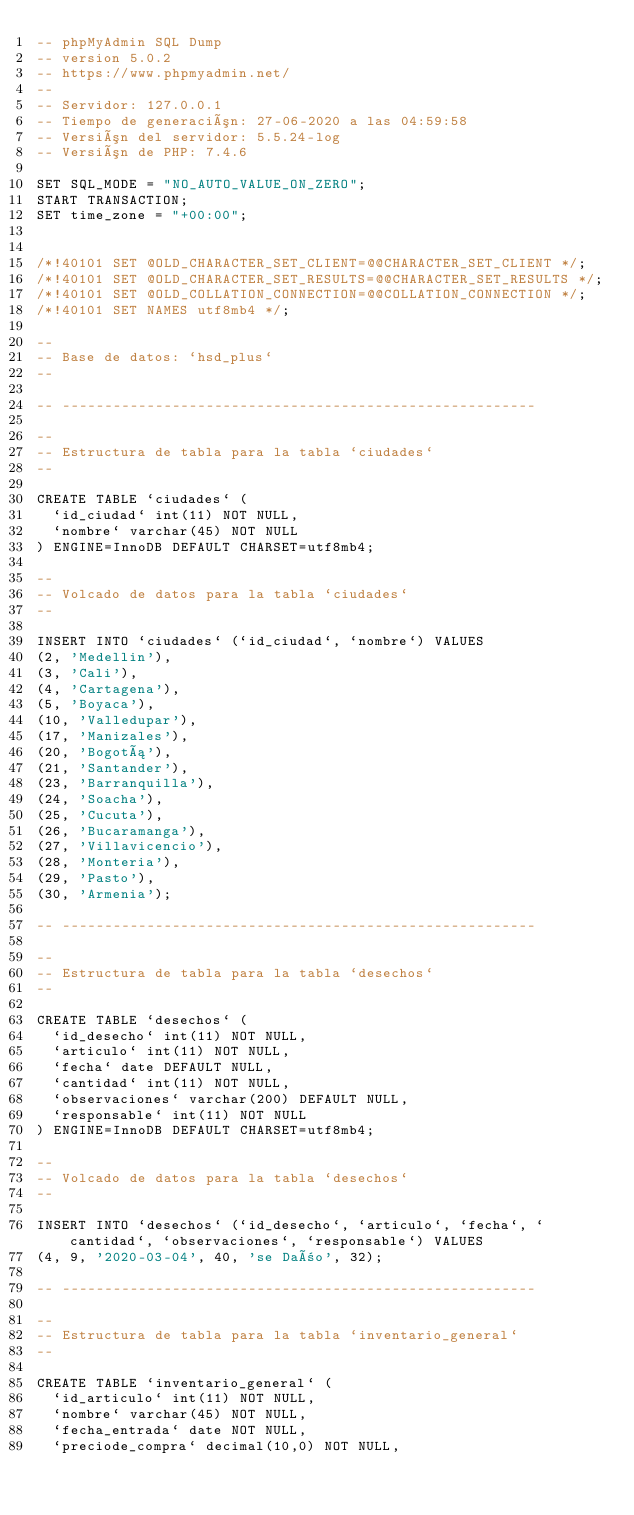<code> <loc_0><loc_0><loc_500><loc_500><_SQL_>-- phpMyAdmin SQL Dump
-- version 5.0.2
-- https://www.phpmyadmin.net/
--
-- Servidor: 127.0.0.1
-- Tiempo de generación: 27-06-2020 a las 04:59:58
-- Versión del servidor: 5.5.24-log
-- Versión de PHP: 7.4.6

SET SQL_MODE = "NO_AUTO_VALUE_ON_ZERO";
START TRANSACTION;
SET time_zone = "+00:00";


/*!40101 SET @OLD_CHARACTER_SET_CLIENT=@@CHARACTER_SET_CLIENT */;
/*!40101 SET @OLD_CHARACTER_SET_RESULTS=@@CHARACTER_SET_RESULTS */;
/*!40101 SET @OLD_COLLATION_CONNECTION=@@COLLATION_CONNECTION */;
/*!40101 SET NAMES utf8mb4 */;

--
-- Base de datos: `hsd_plus`
--

-- --------------------------------------------------------

--
-- Estructura de tabla para la tabla `ciudades`
--

CREATE TABLE `ciudades` (
  `id_ciudad` int(11) NOT NULL,
  `nombre` varchar(45) NOT NULL
) ENGINE=InnoDB DEFAULT CHARSET=utf8mb4;

--
-- Volcado de datos para la tabla `ciudades`
--

INSERT INTO `ciudades` (`id_ciudad`, `nombre`) VALUES
(2, 'Medellin'),
(3, 'Cali'),
(4, 'Cartagena'),
(5, 'Boyaca'),
(10, 'Valledupar'),
(17, 'Manizales'),
(20, 'Bogotá'),
(21, 'Santander'),
(23, 'Barranquilla'),
(24, 'Soacha'),
(25, 'Cucuta'),
(26, 'Bucaramanga'),
(27, 'Villavicencio'),
(28, 'Monteria'),
(29, 'Pasto'),
(30, 'Armenia');

-- --------------------------------------------------------

--
-- Estructura de tabla para la tabla `desechos`
--

CREATE TABLE `desechos` (
  `id_desecho` int(11) NOT NULL,
  `articulo` int(11) NOT NULL,
  `fecha` date DEFAULT NULL,
  `cantidad` int(11) NOT NULL,
  `observaciones` varchar(200) DEFAULT NULL,
  `responsable` int(11) NOT NULL
) ENGINE=InnoDB DEFAULT CHARSET=utf8mb4;

--
-- Volcado de datos para la tabla `desechos`
--

INSERT INTO `desechos` (`id_desecho`, `articulo`, `fecha`, `cantidad`, `observaciones`, `responsable`) VALUES
(4, 9, '2020-03-04', 40, 'se Daño', 32);

-- --------------------------------------------------------

--
-- Estructura de tabla para la tabla `inventario_general`
--

CREATE TABLE `inventario_general` (
  `id_articulo` int(11) NOT NULL,
  `nombre` varchar(45) NOT NULL,
  `fecha_entrada` date NOT NULL,
  `preciode_compra` decimal(10,0) NOT NULL,</code> 